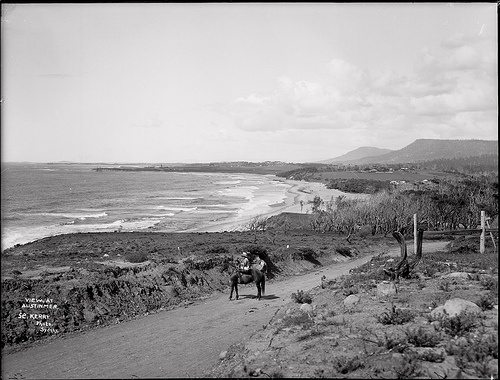Describe the objects in this image and their specific colors. I can see horse in gray, black, and darkgray tones, people in gray, black, darkgray, and lightgray tones, and people in gray, black, darkgray, and lightgray tones in this image. 